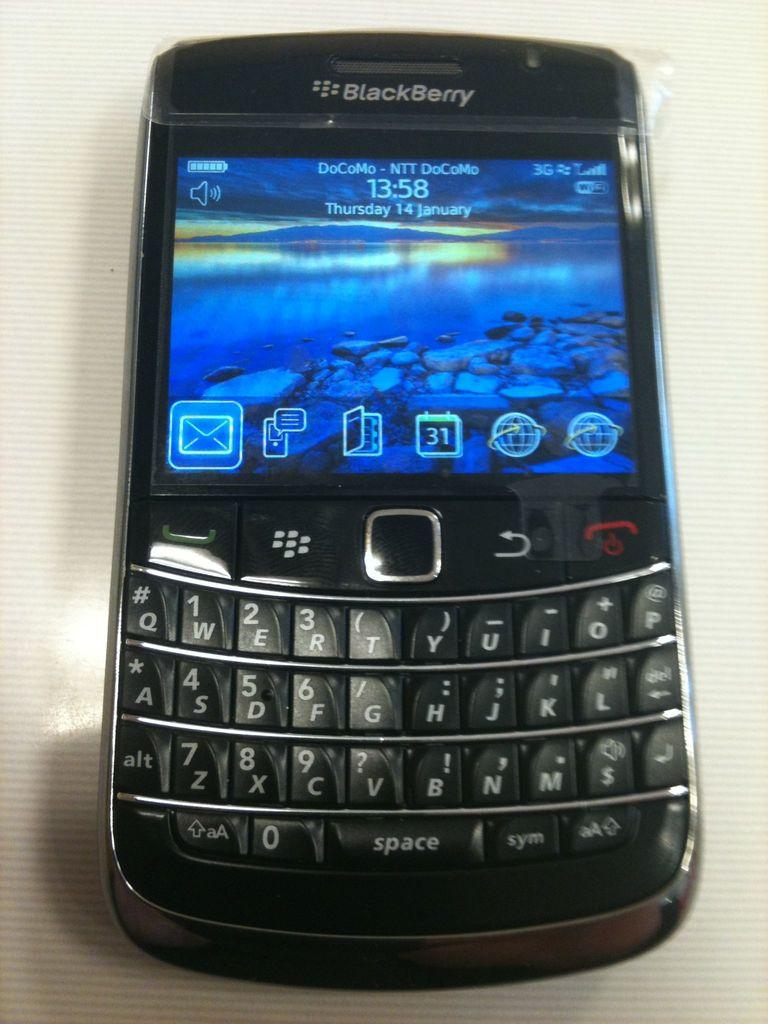<image>
Offer a succinct explanation of the picture presented. A blackberry phone with a blue display on the screen 